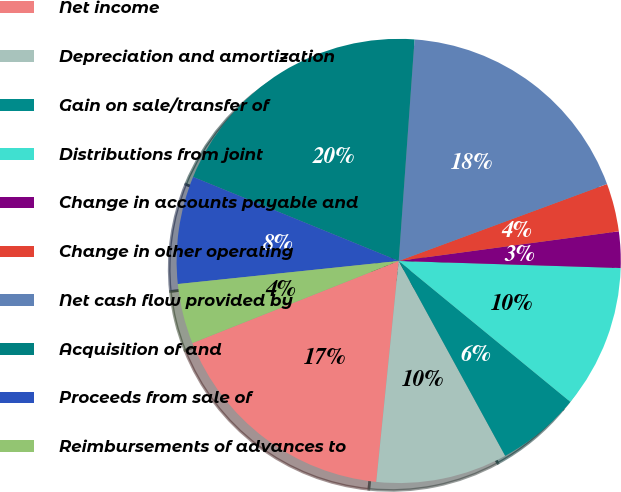<chart> <loc_0><loc_0><loc_500><loc_500><pie_chart><fcel>Net income<fcel>Depreciation and amortization<fcel>Gain on sale/transfer of<fcel>Distributions from joint<fcel>Change in accounts payable and<fcel>Change in other operating<fcel>Net cash flow provided by<fcel>Acquisition of and<fcel>Proceeds from sale of<fcel>Reimbursements of advances to<nl><fcel>17.36%<fcel>9.57%<fcel>6.1%<fcel>10.43%<fcel>2.64%<fcel>3.5%<fcel>18.23%<fcel>19.96%<fcel>7.83%<fcel>4.37%<nl></chart> 